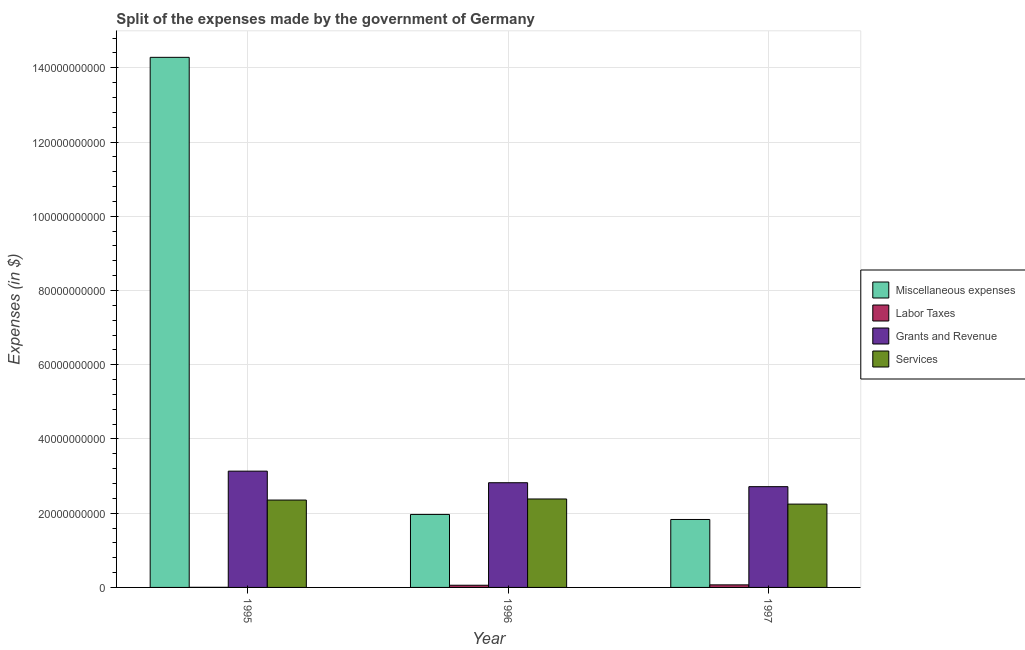How many different coloured bars are there?
Give a very brief answer. 4. How many groups of bars are there?
Your answer should be very brief. 3. Are the number of bars per tick equal to the number of legend labels?
Offer a very short reply. Yes. Are the number of bars on each tick of the X-axis equal?
Keep it short and to the point. Yes. What is the amount spent on grants and revenue in 1996?
Offer a terse response. 2.82e+1. Across all years, what is the maximum amount spent on grants and revenue?
Your answer should be compact. 3.13e+1. Across all years, what is the minimum amount spent on miscellaneous expenses?
Your response must be concise. 1.83e+1. In which year was the amount spent on labor taxes maximum?
Your response must be concise. 1997. In which year was the amount spent on grants and revenue minimum?
Keep it short and to the point. 1997. What is the total amount spent on labor taxes in the graph?
Your answer should be compact. 1.31e+09. What is the difference between the amount spent on grants and revenue in 1995 and that in 1996?
Provide a short and direct response. 3.12e+09. What is the difference between the amount spent on labor taxes in 1995 and the amount spent on services in 1997?
Provide a succinct answer. -6.60e+08. What is the average amount spent on labor taxes per year?
Your answer should be very brief. 4.37e+08. In the year 1997, what is the difference between the amount spent on grants and revenue and amount spent on miscellaneous expenses?
Your answer should be compact. 0. In how many years, is the amount spent on services greater than 28000000000 $?
Provide a succinct answer. 0. What is the ratio of the amount spent on miscellaneous expenses in 1995 to that in 1996?
Your response must be concise. 7.26. Is the amount spent on services in 1996 less than that in 1997?
Give a very brief answer. No. What is the difference between the highest and the second highest amount spent on services?
Keep it short and to the point. 2.90e+08. What is the difference between the highest and the lowest amount spent on services?
Provide a short and direct response. 1.38e+09. What does the 2nd bar from the left in 1996 represents?
Provide a short and direct response. Labor Taxes. What does the 1st bar from the right in 1995 represents?
Provide a succinct answer. Services. Is it the case that in every year, the sum of the amount spent on miscellaneous expenses and amount spent on labor taxes is greater than the amount spent on grants and revenue?
Ensure brevity in your answer.  No. How many bars are there?
Offer a very short reply. 12. Does the graph contain grids?
Offer a very short reply. Yes. Where does the legend appear in the graph?
Make the answer very short. Center right. How many legend labels are there?
Keep it short and to the point. 4. What is the title of the graph?
Offer a terse response. Split of the expenses made by the government of Germany. What is the label or title of the X-axis?
Your response must be concise. Year. What is the label or title of the Y-axis?
Provide a succinct answer. Expenses (in $). What is the Expenses (in $) of Miscellaneous expenses in 1995?
Your response must be concise. 1.43e+11. What is the Expenses (in $) in Labor Taxes in 1995?
Your response must be concise. 3.00e+07. What is the Expenses (in $) of Grants and Revenue in 1995?
Your answer should be compact. 3.13e+1. What is the Expenses (in $) in Services in 1995?
Provide a short and direct response. 2.35e+1. What is the Expenses (in $) in Miscellaneous expenses in 1996?
Give a very brief answer. 1.97e+1. What is the Expenses (in $) of Labor Taxes in 1996?
Make the answer very short. 5.90e+08. What is the Expenses (in $) in Grants and Revenue in 1996?
Offer a terse response. 2.82e+1. What is the Expenses (in $) of Services in 1996?
Keep it short and to the point. 2.38e+1. What is the Expenses (in $) in Miscellaneous expenses in 1997?
Offer a terse response. 1.83e+1. What is the Expenses (in $) in Labor Taxes in 1997?
Provide a short and direct response. 6.90e+08. What is the Expenses (in $) of Grants and Revenue in 1997?
Ensure brevity in your answer.  2.72e+1. What is the Expenses (in $) of Services in 1997?
Ensure brevity in your answer.  2.24e+1. Across all years, what is the maximum Expenses (in $) in Miscellaneous expenses?
Your answer should be very brief. 1.43e+11. Across all years, what is the maximum Expenses (in $) of Labor Taxes?
Ensure brevity in your answer.  6.90e+08. Across all years, what is the maximum Expenses (in $) in Grants and Revenue?
Provide a short and direct response. 3.13e+1. Across all years, what is the maximum Expenses (in $) of Services?
Your answer should be compact. 2.38e+1. Across all years, what is the minimum Expenses (in $) of Miscellaneous expenses?
Offer a terse response. 1.83e+1. Across all years, what is the minimum Expenses (in $) of Labor Taxes?
Provide a succinct answer. 3.00e+07. Across all years, what is the minimum Expenses (in $) in Grants and Revenue?
Offer a terse response. 2.72e+1. Across all years, what is the minimum Expenses (in $) of Services?
Provide a succinct answer. 2.24e+1. What is the total Expenses (in $) in Miscellaneous expenses in the graph?
Offer a very short reply. 1.81e+11. What is the total Expenses (in $) in Labor Taxes in the graph?
Provide a succinct answer. 1.31e+09. What is the total Expenses (in $) in Grants and Revenue in the graph?
Your answer should be very brief. 8.67e+1. What is the total Expenses (in $) of Services in the graph?
Make the answer very short. 6.98e+1. What is the difference between the Expenses (in $) of Miscellaneous expenses in 1995 and that in 1996?
Make the answer very short. 1.23e+11. What is the difference between the Expenses (in $) of Labor Taxes in 1995 and that in 1996?
Your answer should be very brief. -5.60e+08. What is the difference between the Expenses (in $) in Grants and Revenue in 1995 and that in 1996?
Make the answer very short. 3.12e+09. What is the difference between the Expenses (in $) in Services in 1995 and that in 1996?
Make the answer very short. -2.90e+08. What is the difference between the Expenses (in $) of Miscellaneous expenses in 1995 and that in 1997?
Your answer should be very brief. 1.25e+11. What is the difference between the Expenses (in $) of Labor Taxes in 1995 and that in 1997?
Provide a short and direct response. -6.60e+08. What is the difference between the Expenses (in $) in Grants and Revenue in 1995 and that in 1997?
Offer a terse response. 4.18e+09. What is the difference between the Expenses (in $) in Services in 1995 and that in 1997?
Your answer should be very brief. 1.09e+09. What is the difference between the Expenses (in $) of Miscellaneous expenses in 1996 and that in 1997?
Keep it short and to the point. 1.36e+09. What is the difference between the Expenses (in $) in Labor Taxes in 1996 and that in 1997?
Make the answer very short. -1.00e+08. What is the difference between the Expenses (in $) in Grants and Revenue in 1996 and that in 1997?
Offer a very short reply. 1.06e+09. What is the difference between the Expenses (in $) of Services in 1996 and that in 1997?
Your answer should be compact. 1.38e+09. What is the difference between the Expenses (in $) of Miscellaneous expenses in 1995 and the Expenses (in $) of Labor Taxes in 1996?
Keep it short and to the point. 1.42e+11. What is the difference between the Expenses (in $) in Miscellaneous expenses in 1995 and the Expenses (in $) in Grants and Revenue in 1996?
Make the answer very short. 1.15e+11. What is the difference between the Expenses (in $) in Miscellaneous expenses in 1995 and the Expenses (in $) in Services in 1996?
Make the answer very short. 1.19e+11. What is the difference between the Expenses (in $) in Labor Taxes in 1995 and the Expenses (in $) in Grants and Revenue in 1996?
Keep it short and to the point. -2.82e+1. What is the difference between the Expenses (in $) of Labor Taxes in 1995 and the Expenses (in $) of Services in 1996?
Your response must be concise. -2.38e+1. What is the difference between the Expenses (in $) of Grants and Revenue in 1995 and the Expenses (in $) of Services in 1996?
Ensure brevity in your answer.  7.50e+09. What is the difference between the Expenses (in $) in Miscellaneous expenses in 1995 and the Expenses (in $) in Labor Taxes in 1997?
Keep it short and to the point. 1.42e+11. What is the difference between the Expenses (in $) in Miscellaneous expenses in 1995 and the Expenses (in $) in Grants and Revenue in 1997?
Provide a short and direct response. 1.16e+11. What is the difference between the Expenses (in $) of Miscellaneous expenses in 1995 and the Expenses (in $) of Services in 1997?
Provide a succinct answer. 1.20e+11. What is the difference between the Expenses (in $) in Labor Taxes in 1995 and the Expenses (in $) in Grants and Revenue in 1997?
Provide a succinct answer. -2.71e+1. What is the difference between the Expenses (in $) in Labor Taxes in 1995 and the Expenses (in $) in Services in 1997?
Keep it short and to the point. -2.24e+1. What is the difference between the Expenses (in $) of Grants and Revenue in 1995 and the Expenses (in $) of Services in 1997?
Your response must be concise. 8.88e+09. What is the difference between the Expenses (in $) in Miscellaneous expenses in 1996 and the Expenses (in $) in Labor Taxes in 1997?
Offer a terse response. 1.90e+1. What is the difference between the Expenses (in $) in Miscellaneous expenses in 1996 and the Expenses (in $) in Grants and Revenue in 1997?
Provide a succinct answer. -7.48e+09. What is the difference between the Expenses (in $) of Miscellaneous expenses in 1996 and the Expenses (in $) of Services in 1997?
Your response must be concise. -2.78e+09. What is the difference between the Expenses (in $) of Labor Taxes in 1996 and the Expenses (in $) of Grants and Revenue in 1997?
Your response must be concise. -2.66e+1. What is the difference between the Expenses (in $) in Labor Taxes in 1996 and the Expenses (in $) in Services in 1997?
Ensure brevity in your answer.  -2.19e+1. What is the difference between the Expenses (in $) in Grants and Revenue in 1996 and the Expenses (in $) in Services in 1997?
Offer a very short reply. 5.76e+09. What is the average Expenses (in $) in Miscellaneous expenses per year?
Ensure brevity in your answer.  6.03e+1. What is the average Expenses (in $) of Labor Taxes per year?
Make the answer very short. 4.37e+08. What is the average Expenses (in $) of Grants and Revenue per year?
Offer a terse response. 2.89e+1. What is the average Expenses (in $) in Services per year?
Ensure brevity in your answer.  2.33e+1. In the year 1995, what is the difference between the Expenses (in $) in Miscellaneous expenses and Expenses (in $) in Labor Taxes?
Offer a very short reply. 1.43e+11. In the year 1995, what is the difference between the Expenses (in $) of Miscellaneous expenses and Expenses (in $) of Grants and Revenue?
Give a very brief answer. 1.11e+11. In the year 1995, what is the difference between the Expenses (in $) of Miscellaneous expenses and Expenses (in $) of Services?
Ensure brevity in your answer.  1.19e+11. In the year 1995, what is the difference between the Expenses (in $) in Labor Taxes and Expenses (in $) in Grants and Revenue?
Offer a terse response. -3.13e+1. In the year 1995, what is the difference between the Expenses (in $) of Labor Taxes and Expenses (in $) of Services?
Ensure brevity in your answer.  -2.35e+1. In the year 1995, what is the difference between the Expenses (in $) of Grants and Revenue and Expenses (in $) of Services?
Provide a succinct answer. 7.79e+09. In the year 1996, what is the difference between the Expenses (in $) in Miscellaneous expenses and Expenses (in $) in Labor Taxes?
Make the answer very short. 1.91e+1. In the year 1996, what is the difference between the Expenses (in $) in Miscellaneous expenses and Expenses (in $) in Grants and Revenue?
Offer a very short reply. -8.54e+09. In the year 1996, what is the difference between the Expenses (in $) in Miscellaneous expenses and Expenses (in $) in Services?
Ensure brevity in your answer.  -4.16e+09. In the year 1996, what is the difference between the Expenses (in $) in Labor Taxes and Expenses (in $) in Grants and Revenue?
Keep it short and to the point. -2.76e+1. In the year 1996, what is the difference between the Expenses (in $) in Labor Taxes and Expenses (in $) in Services?
Make the answer very short. -2.32e+1. In the year 1996, what is the difference between the Expenses (in $) of Grants and Revenue and Expenses (in $) of Services?
Provide a succinct answer. 4.38e+09. In the year 1997, what is the difference between the Expenses (in $) of Miscellaneous expenses and Expenses (in $) of Labor Taxes?
Ensure brevity in your answer.  1.76e+1. In the year 1997, what is the difference between the Expenses (in $) of Miscellaneous expenses and Expenses (in $) of Grants and Revenue?
Keep it short and to the point. -8.84e+09. In the year 1997, what is the difference between the Expenses (in $) in Miscellaneous expenses and Expenses (in $) in Services?
Offer a terse response. -4.14e+09. In the year 1997, what is the difference between the Expenses (in $) of Labor Taxes and Expenses (in $) of Grants and Revenue?
Provide a succinct answer. -2.65e+1. In the year 1997, what is the difference between the Expenses (in $) in Labor Taxes and Expenses (in $) in Services?
Make the answer very short. -2.18e+1. In the year 1997, what is the difference between the Expenses (in $) in Grants and Revenue and Expenses (in $) in Services?
Your answer should be compact. 4.70e+09. What is the ratio of the Expenses (in $) in Miscellaneous expenses in 1995 to that in 1996?
Your response must be concise. 7.26. What is the ratio of the Expenses (in $) of Labor Taxes in 1995 to that in 1996?
Offer a terse response. 0.05. What is the ratio of the Expenses (in $) of Grants and Revenue in 1995 to that in 1996?
Offer a terse response. 1.11. What is the ratio of the Expenses (in $) in Services in 1995 to that in 1996?
Provide a succinct answer. 0.99. What is the ratio of the Expenses (in $) of Miscellaneous expenses in 1995 to that in 1997?
Ensure brevity in your answer.  7.8. What is the ratio of the Expenses (in $) of Labor Taxes in 1995 to that in 1997?
Make the answer very short. 0.04. What is the ratio of the Expenses (in $) in Grants and Revenue in 1995 to that in 1997?
Make the answer very short. 1.15. What is the ratio of the Expenses (in $) in Services in 1995 to that in 1997?
Your answer should be compact. 1.05. What is the ratio of the Expenses (in $) of Miscellaneous expenses in 1996 to that in 1997?
Keep it short and to the point. 1.07. What is the ratio of the Expenses (in $) of Labor Taxes in 1996 to that in 1997?
Offer a very short reply. 0.86. What is the ratio of the Expenses (in $) of Grants and Revenue in 1996 to that in 1997?
Make the answer very short. 1.04. What is the ratio of the Expenses (in $) of Services in 1996 to that in 1997?
Provide a short and direct response. 1.06. What is the difference between the highest and the second highest Expenses (in $) of Miscellaneous expenses?
Give a very brief answer. 1.23e+11. What is the difference between the highest and the second highest Expenses (in $) in Labor Taxes?
Provide a succinct answer. 1.00e+08. What is the difference between the highest and the second highest Expenses (in $) in Grants and Revenue?
Your answer should be compact. 3.12e+09. What is the difference between the highest and the second highest Expenses (in $) in Services?
Ensure brevity in your answer.  2.90e+08. What is the difference between the highest and the lowest Expenses (in $) in Miscellaneous expenses?
Provide a succinct answer. 1.25e+11. What is the difference between the highest and the lowest Expenses (in $) of Labor Taxes?
Offer a terse response. 6.60e+08. What is the difference between the highest and the lowest Expenses (in $) of Grants and Revenue?
Make the answer very short. 4.18e+09. What is the difference between the highest and the lowest Expenses (in $) in Services?
Offer a terse response. 1.38e+09. 